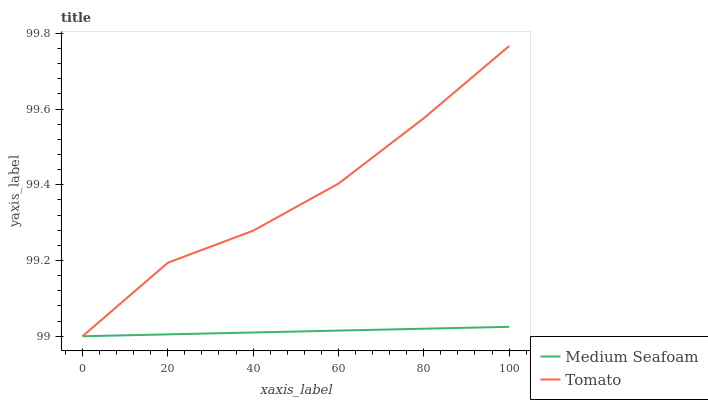Does Medium Seafoam have the minimum area under the curve?
Answer yes or no. Yes. Does Tomato have the maximum area under the curve?
Answer yes or no. Yes. Does Medium Seafoam have the maximum area under the curve?
Answer yes or no. No. Is Medium Seafoam the smoothest?
Answer yes or no. Yes. Is Tomato the roughest?
Answer yes or no. Yes. Is Medium Seafoam the roughest?
Answer yes or no. No. Does Tomato have the lowest value?
Answer yes or no. Yes. Does Tomato have the highest value?
Answer yes or no. Yes. Does Medium Seafoam have the highest value?
Answer yes or no. No. Does Medium Seafoam intersect Tomato?
Answer yes or no. Yes. Is Medium Seafoam less than Tomato?
Answer yes or no. No. Is Medium Seafoam greater than Tomato?
Answer yes or no. No. 